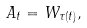Convert formula to latex. <formula><loc_0><loc_0><loc_500><loc_500>A _ { t } = W _ { \tau ( t ) } ,</formula> 